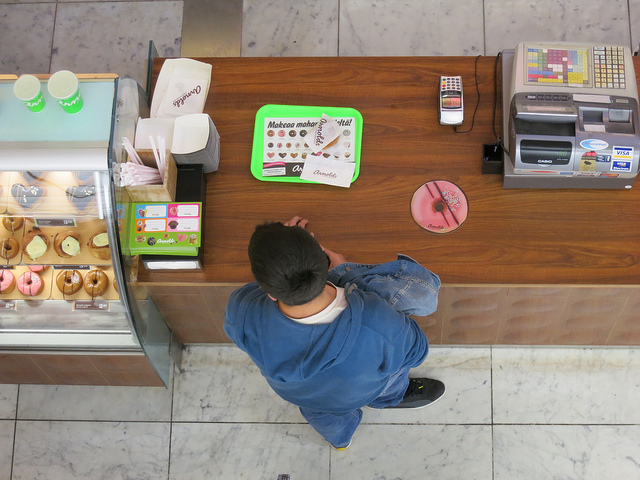Identify the text contained in this image. Visa 